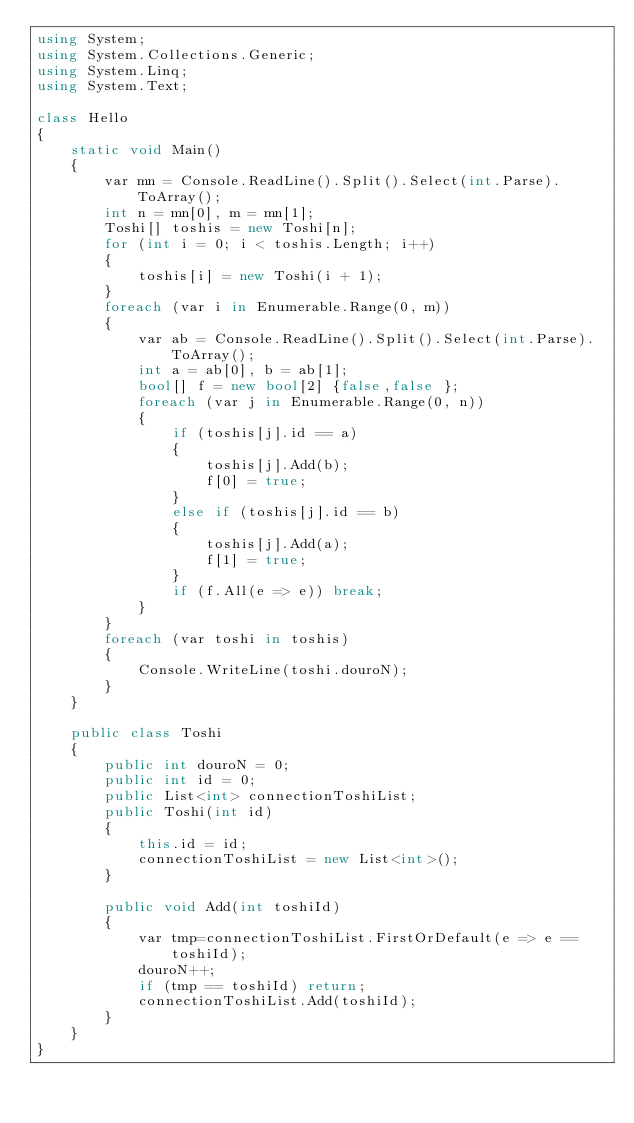<code> <loc_0><loc_0><loc_500><loc_500><_C#_>using System;
using System.Collections.Generic;
using System.Linq;
using System.Text;

class Hello
{
    static void Main()
    {
        var mn = Console.ReadLine().Split().Select(int.Parse).ToArray();
        int n = mn[0], m = mn[1];
        Toshi[] toshis = new Toshi[n];
        for (int i = 0; i < toshis.Length; i++)
        {
            toshis[i] = new Toshi(i + 1);
        }
        foreach (var i in Enumerable.Range(0, m))
        {
            var ab = Console.ReadLine().Split().Select(int.Parse).ToArray();
            int a = ab[0], b = ab[1];
            bool[] f = new bool[2] {false,false };
            foreach (var j in Enumerable.Range(0, n))
            {
                if (toshis[j].id == a)
                {
                    toshis[j].Add(b);
                    f[0] = true;
                }
                else if (toshis[j].id == b)
                {
                    toshis[j].Add(a);
                    f[1] = true;
                }
                if (f.All(e => e)) break;
            }
        }
        foreach (var toshi in toshis)
        {
            Console.WriteLine(toshi.douroN);
        }
    }

    public class Toshi
    {
        public int douroN = 0;
        public int id = 0;
        public List<int> connectionToshiList;
        public Toshi(int id)
        {
            this.id = id;
            connectionToshiList = new List<int>();
        }

        public void Add(int toshiId)
        {
            var tmp=connectionToshiList.FirstOrDefault(e => e == toshiId);
            douroN++;
            if (tmp == toshiId) return;
            connectionToshiList.Add(toshiId);
        }
    }
}</code> 